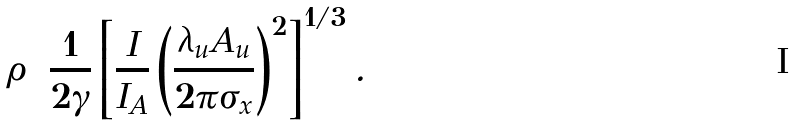<formula> <loc_0><loc_0><loc_500><loc_500>\rho = \frac { 1 } { 2 \gamma } \left [ \frac { I } { I _ { A } } \left ( \frac { \lambda _ { u } A _ { u } } { 2 \pi \sigma _ { x } } \right ) ^ { 2 } \right ] ^ { 1 / 3 } .</formula> 